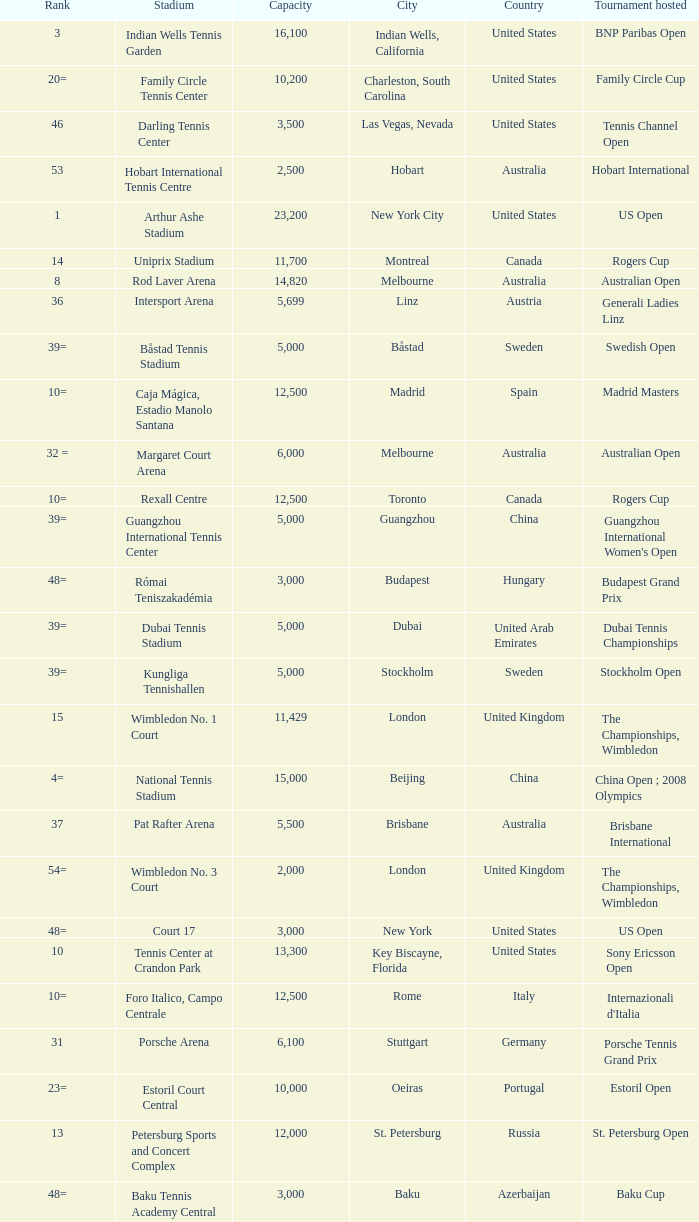What is the average capacity that has rod laver arena as the stadium? 14820.0. 